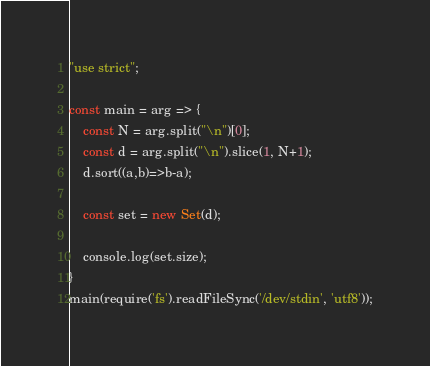Convert code to text. <code><loc_0><loc_0><loc_500><loc_500><_JavaScript_>"use strict";
    
const main = arg => {
    const N = arg.split("\n")[0];
    const d = arg.split("\n").slice(1, N+1);
    d.sort((a,b)=>b-a);
    
    const set = new Set(d);
    
    console.log(set.size);
}
main(require('fs').readFileSync('/dev/stdin', 'utf8'));</code> 